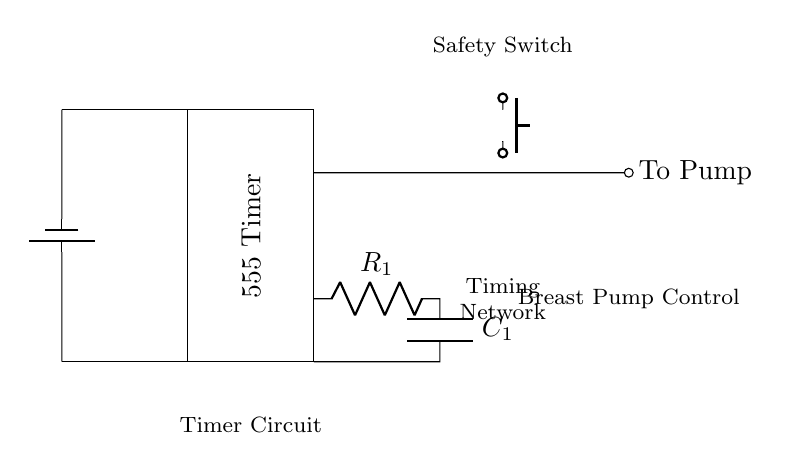What is the main component of this circuit? The main component, indicated by the rectangle, is the 555 Timer. It serves as the timing mechanism for the circuit.
Answer: 555 Timer What does the R1 component represent? R1 represents a resistor, which is part of the timing network in this circuit, controlling the charging and discharging of the capacitor.
Answer: Resistor How does the pump get activated? The pump is activated through the output of the AND gate when both the timer and the safety switch conditions are met.
Answer: Output of the AND gate What is the function of the safety switch? The safety switch prevents the pump from activating unless it is intentionally pressed, ensuring safe operation of the circuit.
Answer: Prevents activation What type of logic gate is used in this circuit? The circuit uses an AND gate, which requires both inputs to be high for the output to be high, allowing safe operation of the pump.
Answer: AND gate If the safety switch is not pressed, what happens to the output? If the safety switch is not pressed, the input to the AND gate is low, resulting in a low output, and thus the pump remains off.
Answer: Pump remains off What validates the timer circuit operation? The operation is validated by the timing network composed of R1 and C1, which determines how long the pump will be active based on their values.
Answer: R1 and C1 